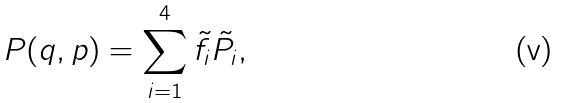Convert formula to latex. <formula><loc_0><loc_0><loc_500><loc_500>P ( q , p ) = \sum _ { i = 1 } ^ { 4 } \tilde { f } _ { i } \tilde { P } _ { i } ,</formula> 